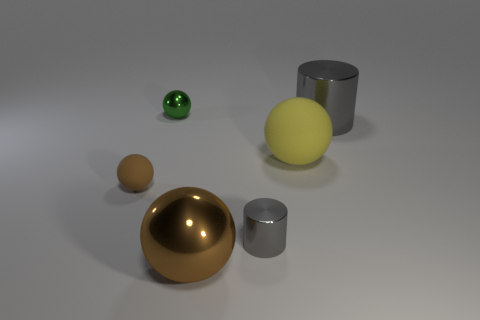What color is the tiny object that is behind the gray metal thing that is behind the gray cylinder to the left of the yellow sphere?
Your answer should be very brief. Green. What is the material of the tiny green object that is the same shape as the yellow rubber thing?
Give a very brief answer. Metal. The small metallic cylinder has what color?
Your response must be concise. Gray. Do the large cylinder and the large matte ball have the same color?
Your answer should be very brief. No. How many rubber things are tiny balls or yellow spheres?
Your answer should be compact. 2. Is there a small green ball to the right of the brown object in front of the small gray cylinder that is to the left of the large gray metallic object?
Offer a terse response. No. There is a green sphere that is made of the same material as the large brown sphere; what size is it?
Offer a very short reply. Small. Are there any green metal spheres in front of the big brown shiny object?
Ensure brevity in your answer.  No. Are there any tiny green spheres that are behind the gray shiny cylinder on the left side of the big matte object?
Make the answer very short. Yes. There is a cylinder that is to the right of the tiny gray shiny thing; does it have the same size as the matte object that is right of the tiny brown object?
Your response must be concise. Yes. 